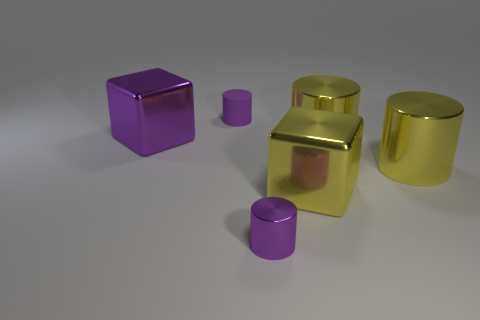What number of objects are large yellow cubes or purple cubes?
Make the answer very short. 2. How many other objects are there of the same color as the rubber cylinder?
Give a very brief answer. 2. There is a purple thing that is the same size as the purple metal cylinder; what shape is it?
Your answer should be very brief. Cylinder. There is a shiny cube left of the small purple rubber object; what is its color?
Keep it short and to the point. Purple. How many things are either tiny things that are behind the big yellow shiny block or small things that are in front of the big purple cube?
Provide a short and direct response. 2. Do the purple block and the yellow metal cube have the same size?
Provide a succinct answer. Yes. How many blocks are either large purple metal objects or tiny rubber things?
Offer a terse response. 1. How many purple things are both in front of the purple matte cylinder and on the right side of the big purple cube?
Provide a succinct answer. 1. Is the size of the purple metal cylinder the same as the metal object on the left side of the matte cylinder?
Your response must be concise. No. Is there a big metal thing that is behind the small purple thing that is in front of the big metallic block that is right of the purple cube?
Provide a succinct answer. Yes. 